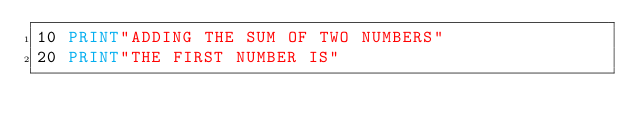Convert code to text. <code><loc_0><loc_0><loc_500><loc_500><_VisualBasic_>10 PRINT"ADDING THE SUM OF TWO NUMBERS"
20 PRINT"THE FIRST NUMBER IS"
</code> 